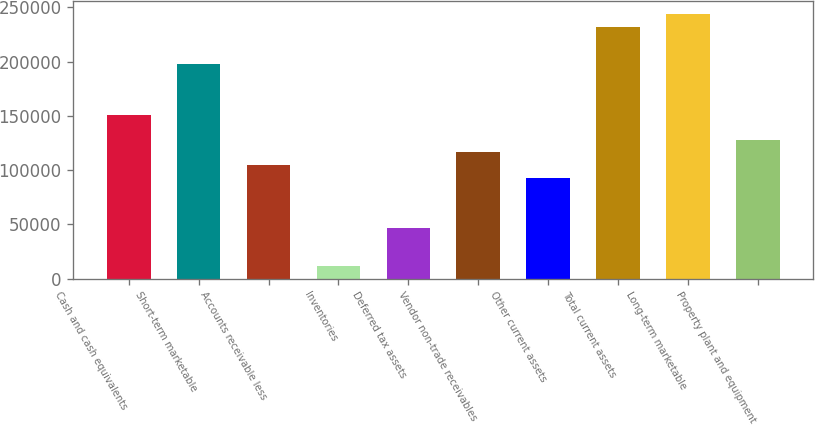Convert chart to OTSL. <chart><loc_0><loc_0><loc_500><loc_500><bar_chart><fcel>Cash and cash equivalents<fcel>Short-term marketable<fcel>Accounts receivable less<fcel>Inventories<fcel>Deferred tax assets<fcel>Vendor non-trade receivables<fcel>Other current assets<fcel>Total current assets<fcel>Long-term marketable<fcel>Property plant and equipment<nl><fcel>151149<fcel>197521<fcel>104778<fcel>12035.8<fcel>46814.2<fcel>116371<fcel>93185.4<fcel>232299<fcel>243892<fcel>127964<nl></chart> 